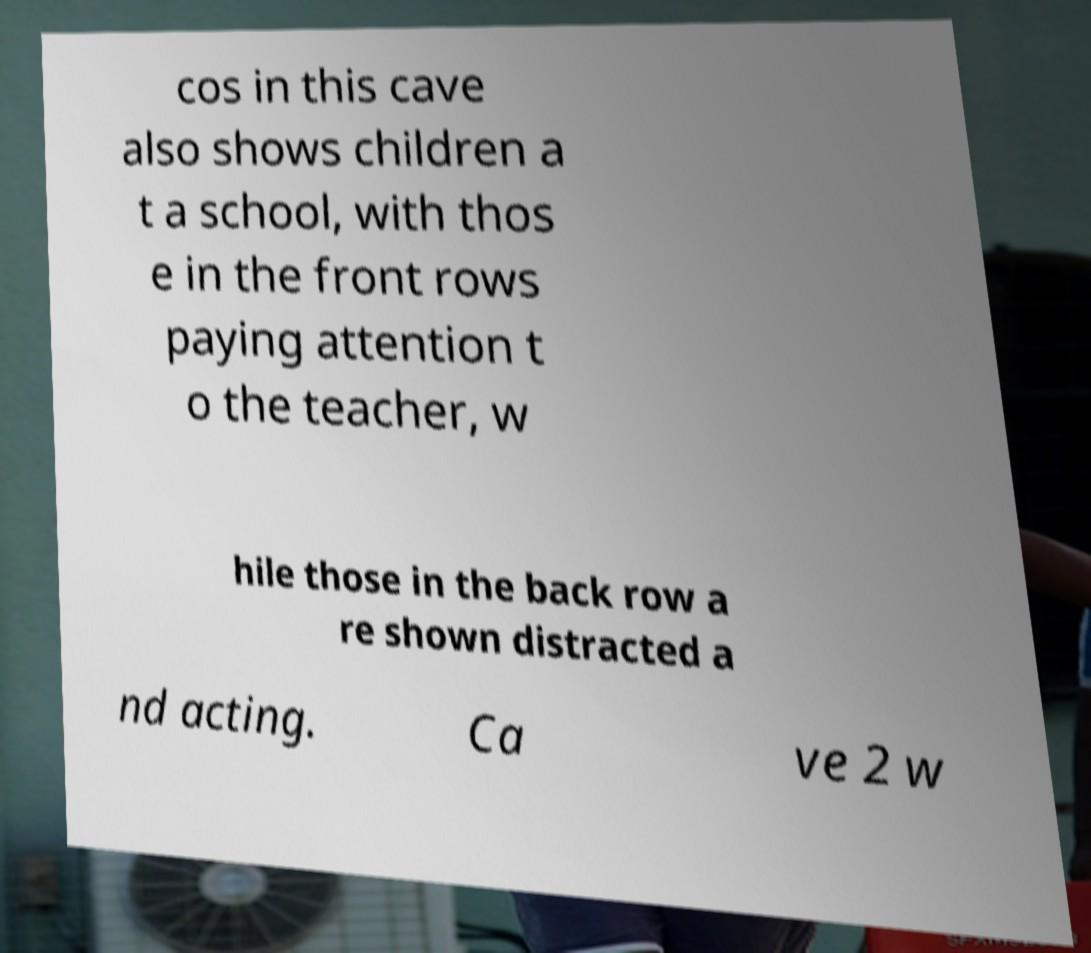What messages or text are displayed in this image? I need them in a readable, typed format. cos in this cave also shows children a t a school, with thos e in the front rows paying attention t o the teacher, w hile those in the back row a re shown distracted a nd acting. Ca ve 2 w 